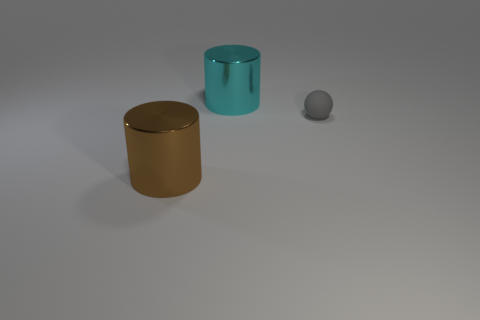Add 2 cylinders. How many objects exist? 5 Subtract all cylinders. How many objects are left? 1 Add 3 big brown cylinders. How many big brown cylinders are left? 4 Add 1 big cylinders. How many big cylinders exist? 3 Subtract 0 blue balls. How many objects are left? 3 Subtract all small gray rubber spheres. Subtract all small spheres. How many objects are left? 1 